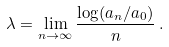Convert formula to latex. <formula><loc_0><loc_0><loc_500><loc_500>\lambda = \lim _ { n \to \infty } \frac { \log ( a _ { n } / a _ { 0 } ) } { n } \, .</formula> 